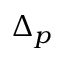<formula> <loc_0><loc_0><loc_500><loc_500>\Delta _ { p }</formula> 